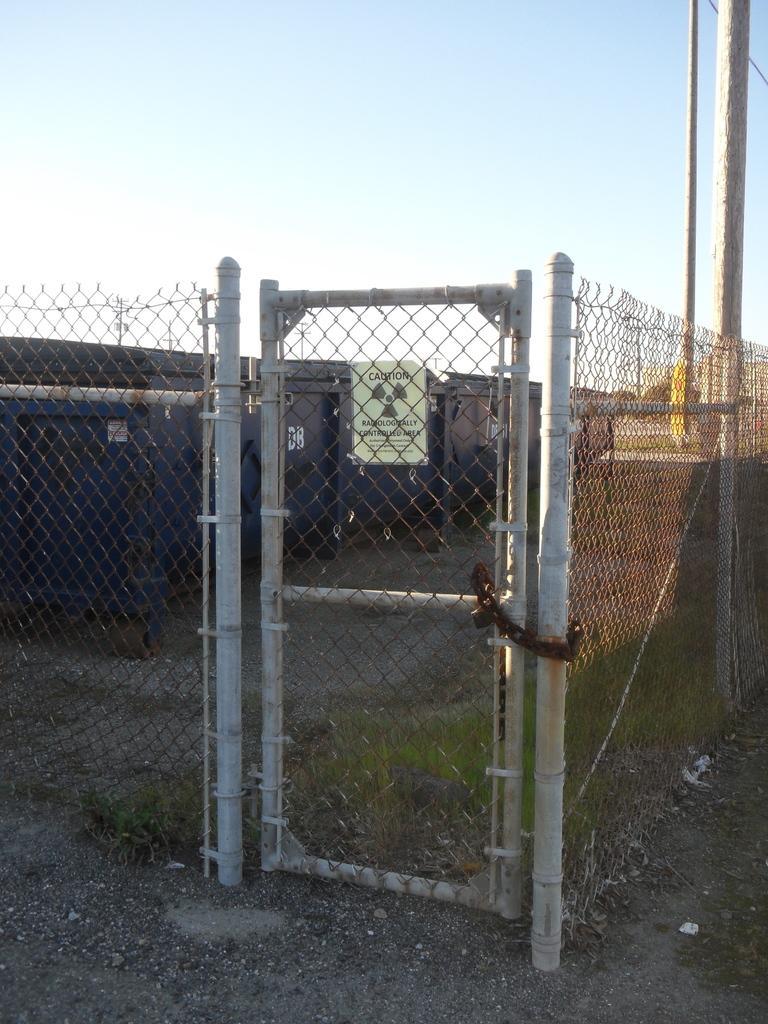Can you describe this image briefly? In this picture I can see fence and a door. In the background I can see building, poles and sky. 